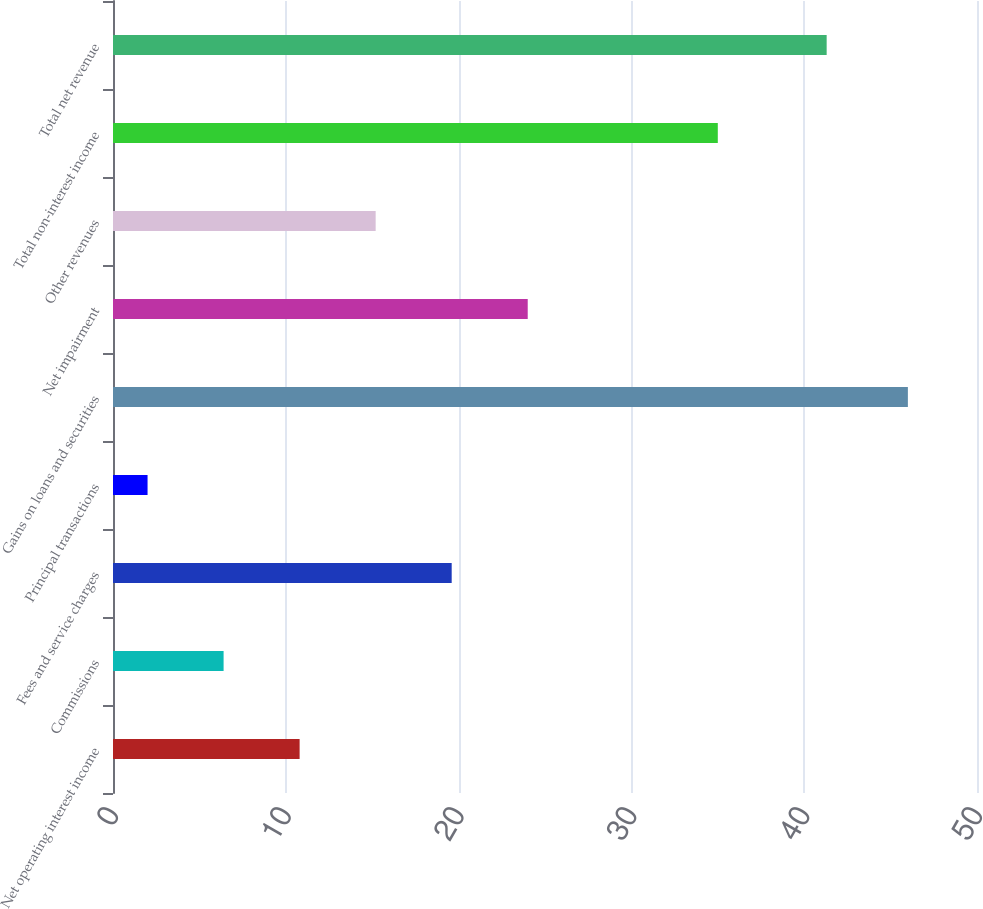<chart> <loc_0><loc_0><loc_500><loc_500><bar_chart><fcel>Net operating interest income<fcel>Commissions<fcel>Fees and service charges<fcel>Principal transactions<fcel>Gains on loans and securities<fcel>Net impairment<fcel>Other revenues<fcel>Total non-interest income<fcel>Total net revenue<nl><fcel>10.8<fcel>6.4<fcel>19.6<fcel>2<fcel>46<fcel>24<fcel>15.2<fcel>35<fcel>41.3<nl></chart> 